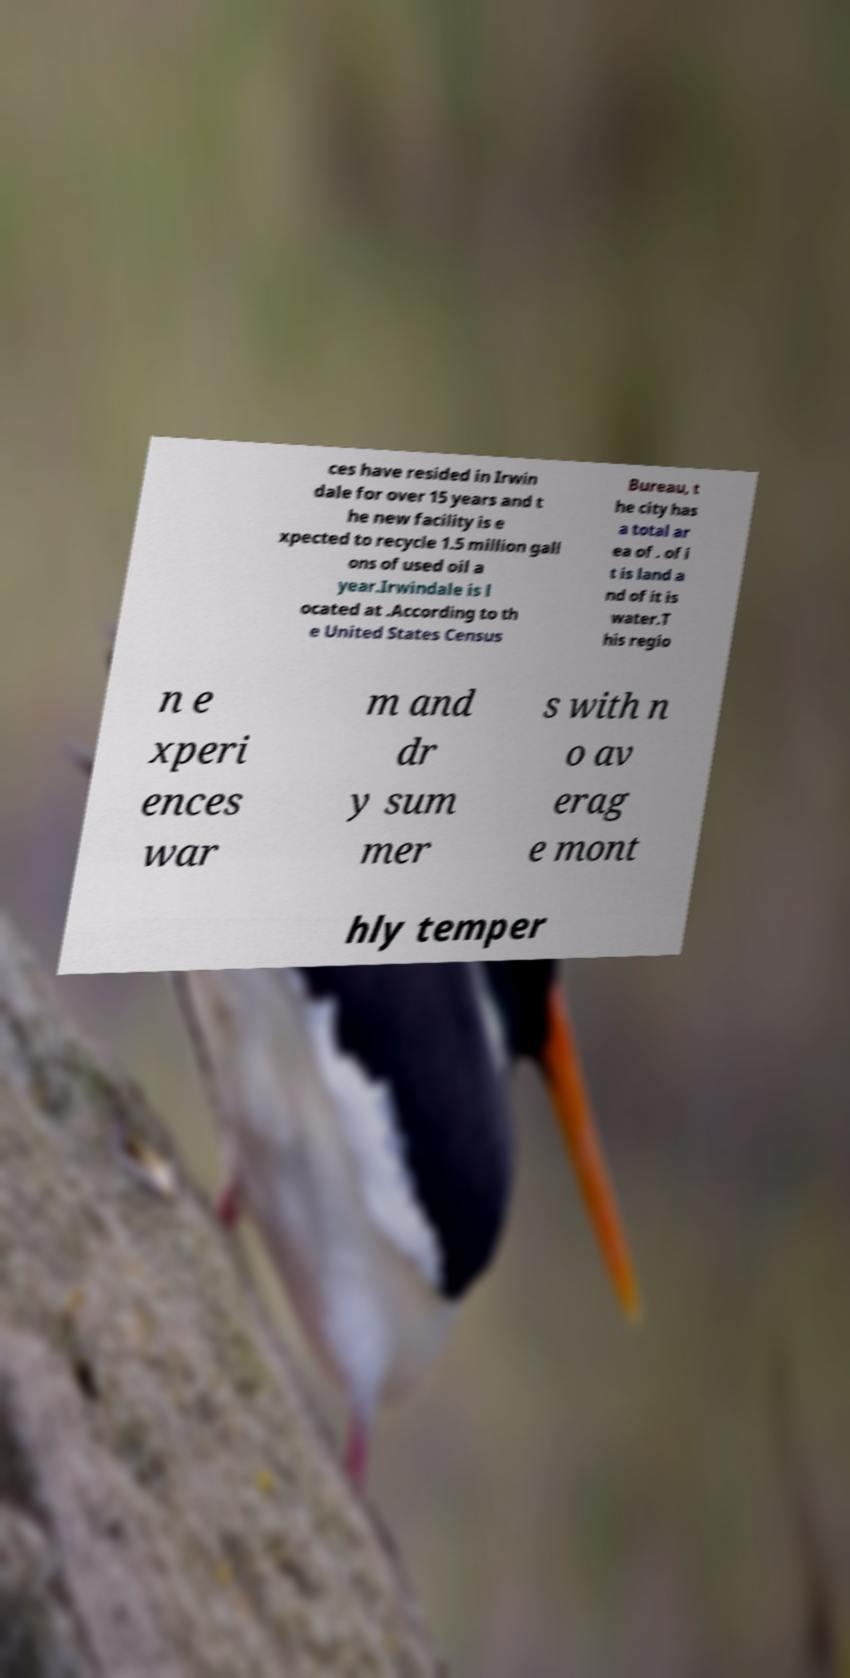Can you accurately transcribe the text from the provided image for me? ces have resided in Irwin dale for over 15 years and t he new facility is e xpected to recycle 1.5 million gall ons of used oil a year.Irwindale is l ocated at .According to th e United States Census Bureau, t he city has a total ar ea of . of i t is land a nd of it is water.T his regio n e xperi ences war m and dr y sum mer s with n o av erag e mont hly temper 